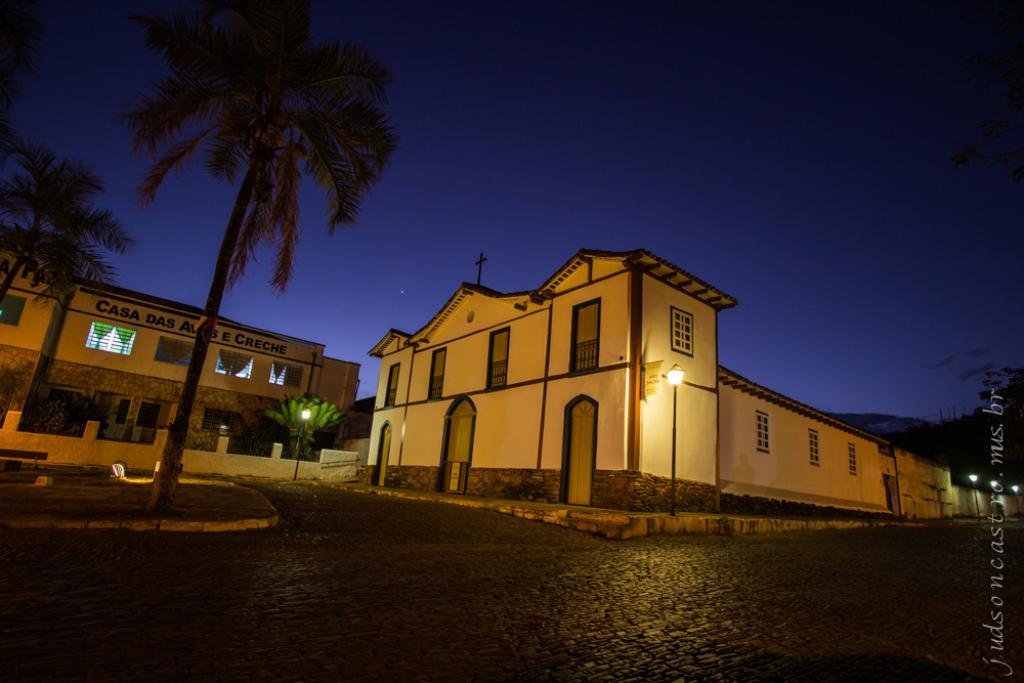What type of structures can be seen in the image? There are buildings in the image. What feature can be observed on the buildings? There are windows visible on the buildings. What type of vegetation is present in the image? There are trees in the image. What type of illumination is present in the image? There are lights in the image. What can be seen in the background of the image? The sky is visible in the background of the image. What type of kite is being flown by the person in the image? There is no person or kite present in the image. How many degrees can be seen in the image? There is no reference to degrees in the image. 